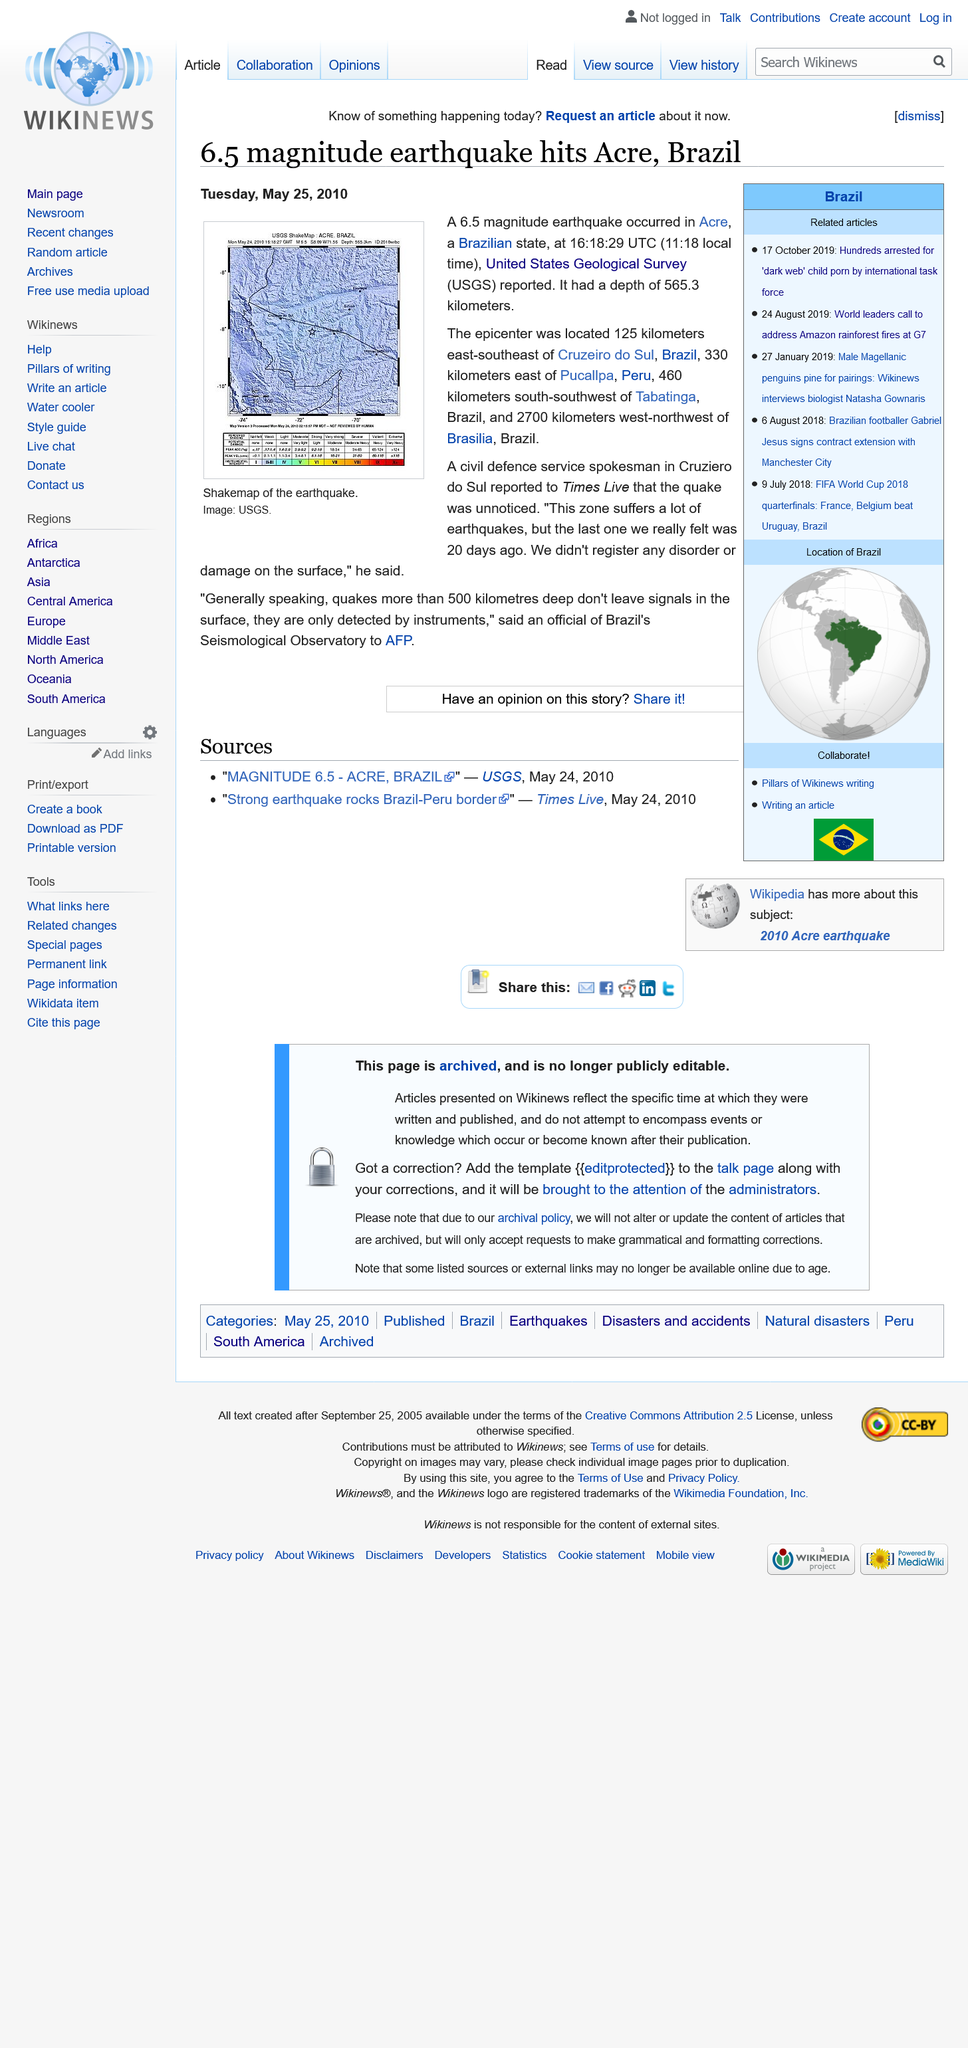Indicate a few pertinent items in this graphic. The earthquake was 2,700 kilometers away from Brasilia. The article was published on May 25th, 2010. The earthquake was a 6.5 magnitude earthquake. 